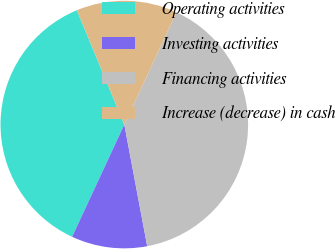<chart> <loc_0><loc_0><loc_500><loc_500><pie_chart><fcel>Operating activities<fcel>Investing activities<fcel>Financing activities<fcel>Increase (decrease) in cash<nl><fcel>36.81%<fcel>9.89%<fcel>40.11%<fcel>13.19%<nl></chart> 